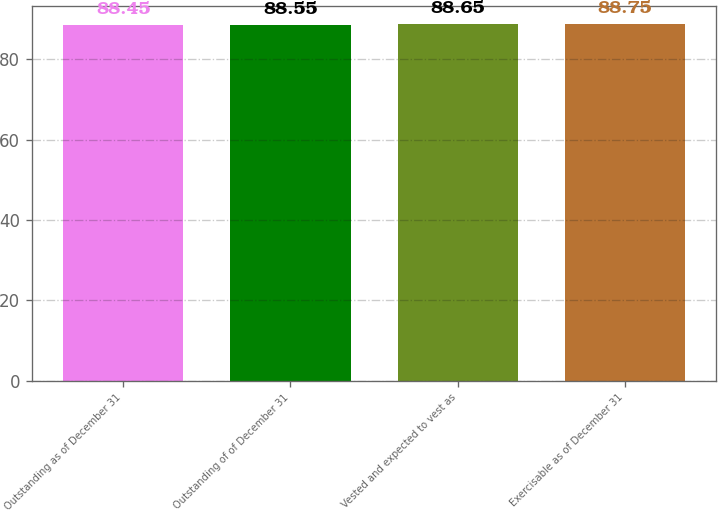Convert chart. <chart><loc_0><loc_0><loc_500><loc_500><bar_chart><fcel>Outstanding as of December 31<fcel>Outstanding of of December 31<fcel>Vested and expected to vest as<fcel>Exercisable as of December 31<nl><fcel>88.45<fcel>88.55<fcel>88.65<fcel>88.75<nl></chart> 